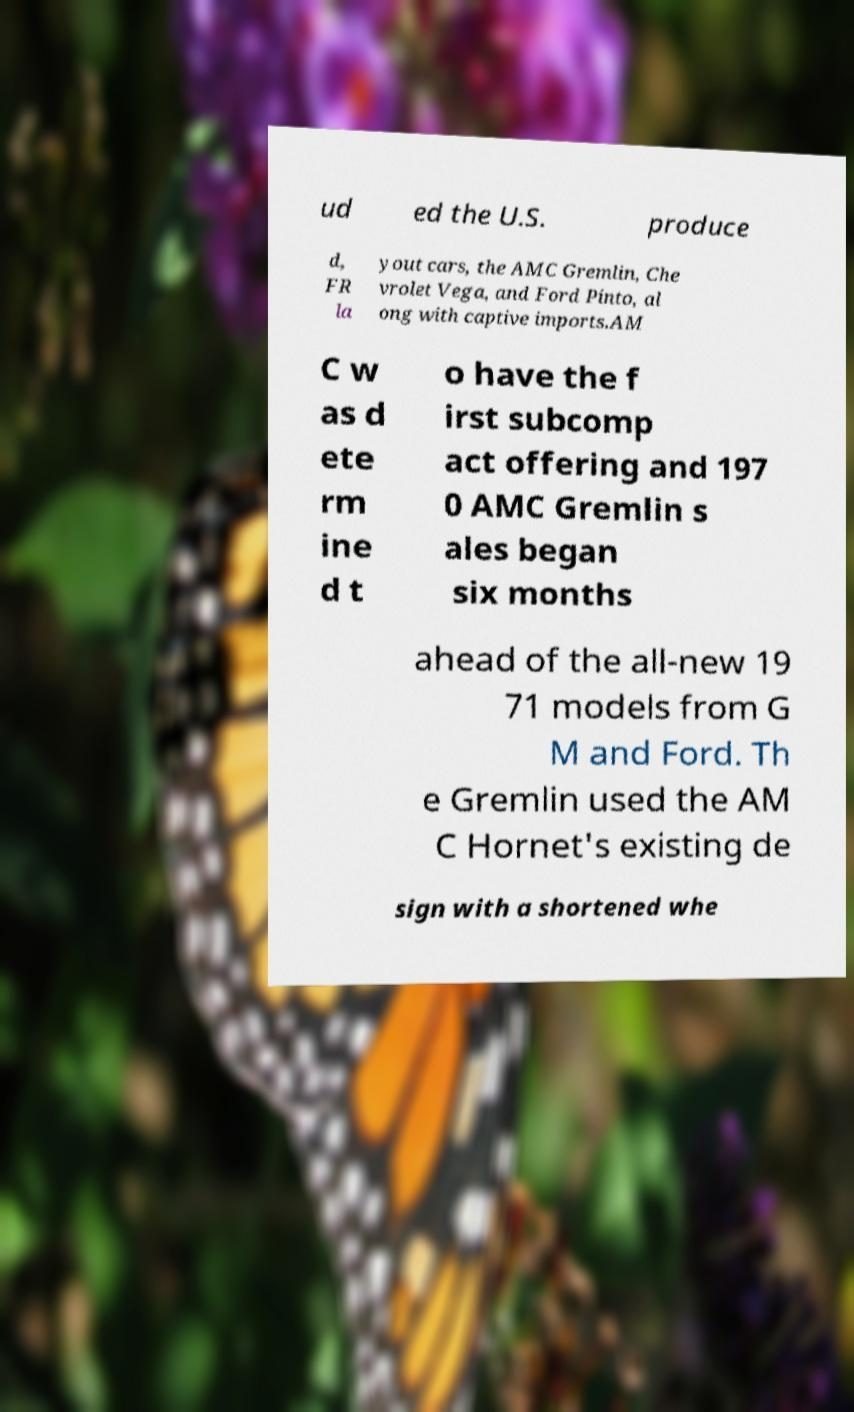I need the written content from this picture converted into text. Can you do that? ud ed the U.S. produce d, FR la yout cars, the AMC Gremlin, Che vrolet Vega, and Ford Pinto, al ong with captive imports.AM C w as d ete rm ine d t o have the f irst subcomp act offering and 197 0 AMC Gremlin s ales began six months ahead of the all-new 19 71 models from G M and Ford. Th e Gremlin used the AM C Hornet's existing de sign with a shortened whe 